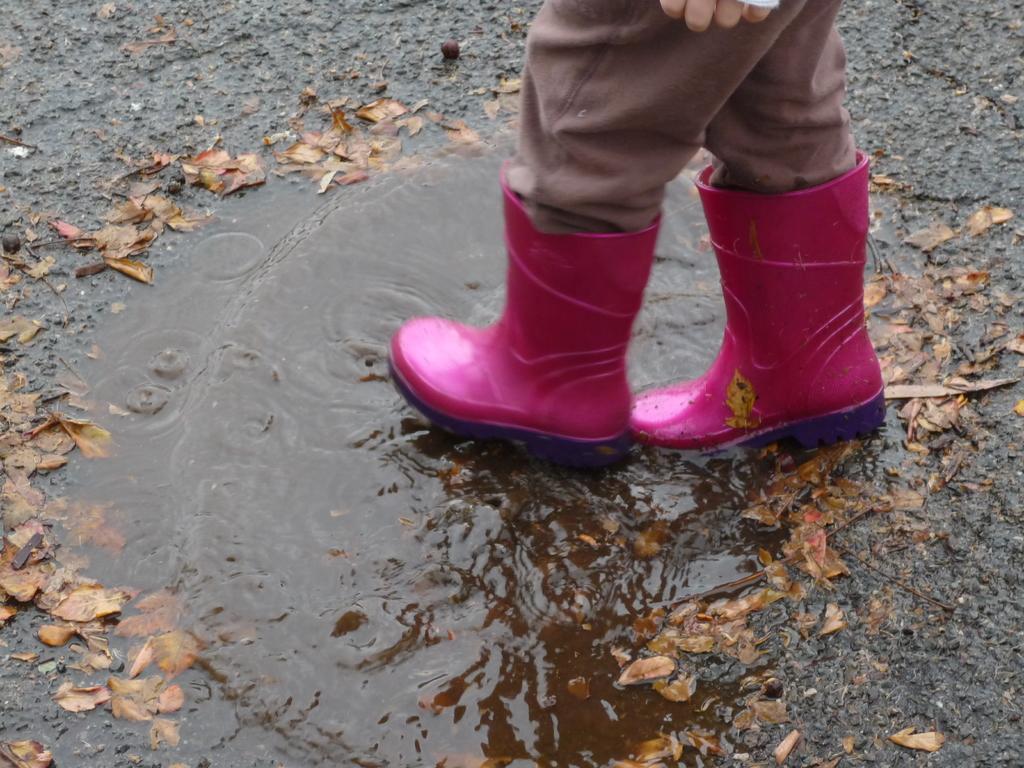How would you summarize this image in a sentence or two? In this picture we can see a person standing, at the bottom there are some leaves and water, this person wore shoes. 